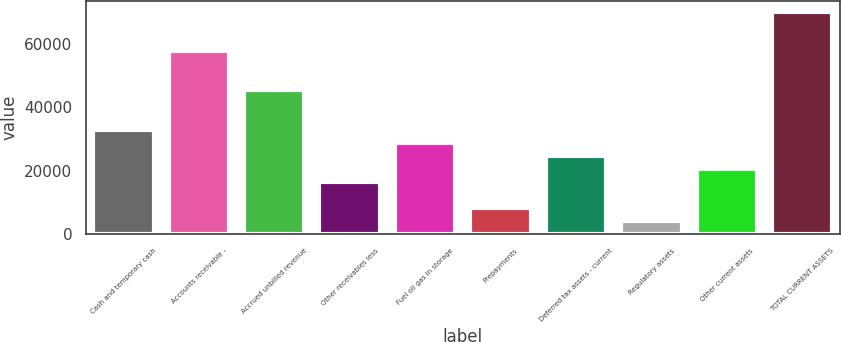Convert chart to OTSL. <chart><loc_0><loc_0><loc_500><loc_500><bar_chart><fcel>Cash and temporary cash<fcel>Accounts receivable -<fcel>Accrued unbilled revenue<fcel>Other receivables less<fcel>Fuel oil gas in storage<fcel>Prepayments<fcel>Deferred tax assets - current<fcel>Regulatory assets<fcel>Other current assets<fcel>TOTAL CURRENT ASSETS<nl><fcel>32967.6<fcel>57691.8<fcel>45329.7<fcel>16484.8<fcel>28846.9<fcel>8243.4<fcel>24726.2<fcel>4122.7<fcel>20605.5<fcel>70053.9<nl></chart> 